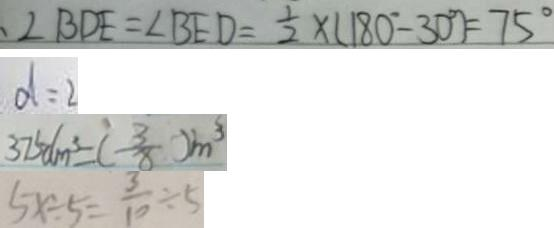<formula> <loc_0><loc_0><loc_500><loc_500>、 \angle B D E = \angle B E D = \frac { 1 } { 2 } \times ( 1 8 0 ^ { \circ } - 3 0 ^ { \circ } ) = 7 5 ^ { \circ } 
 d = 2 
 3 7 5 d m ^ { 3 } = ( - \frac { 3 } { 8 } ) m ^ { 3 } 
 5 x \div 5 = \frac { 3 } { 1 0 } \div 5</formula> 